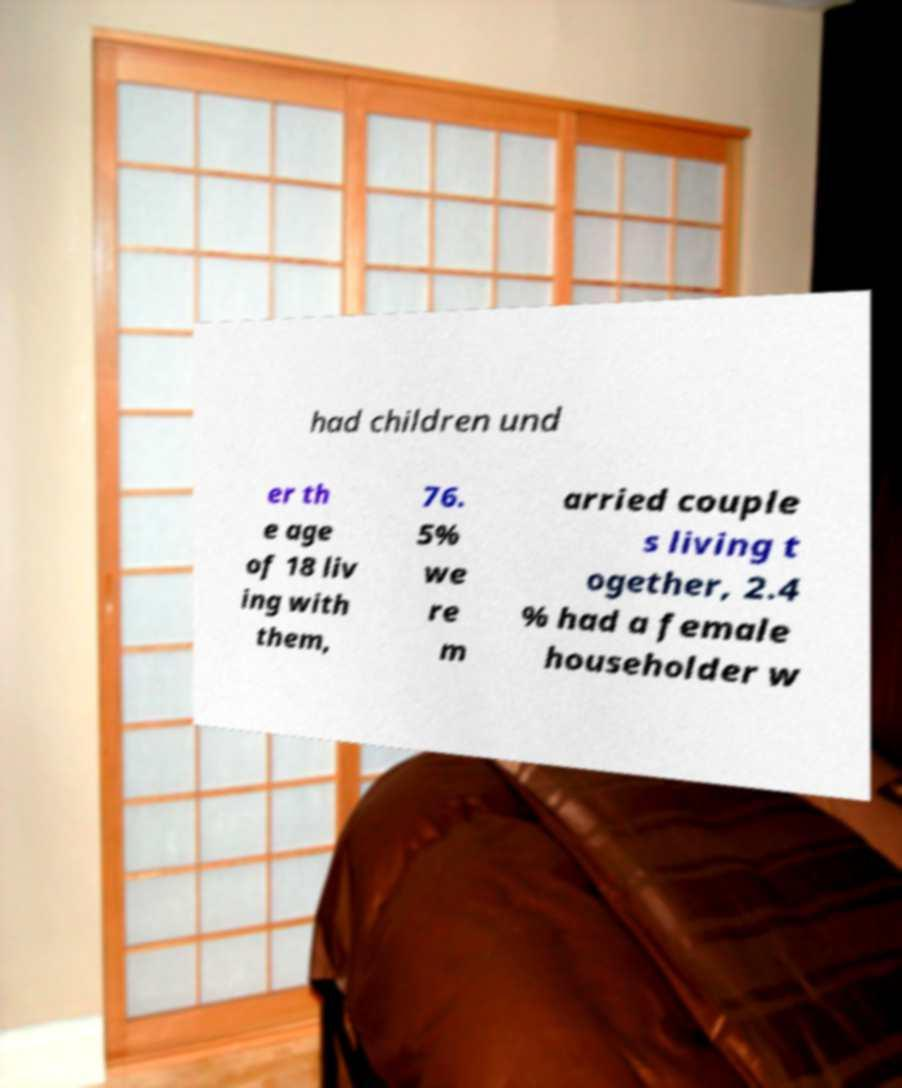Please identify and transcribe the text found in this image. had children und er th e age of 18 liv ing with them, 76. 5% we re m arried couple s living t ogether, 2.4 % had a female householder w 